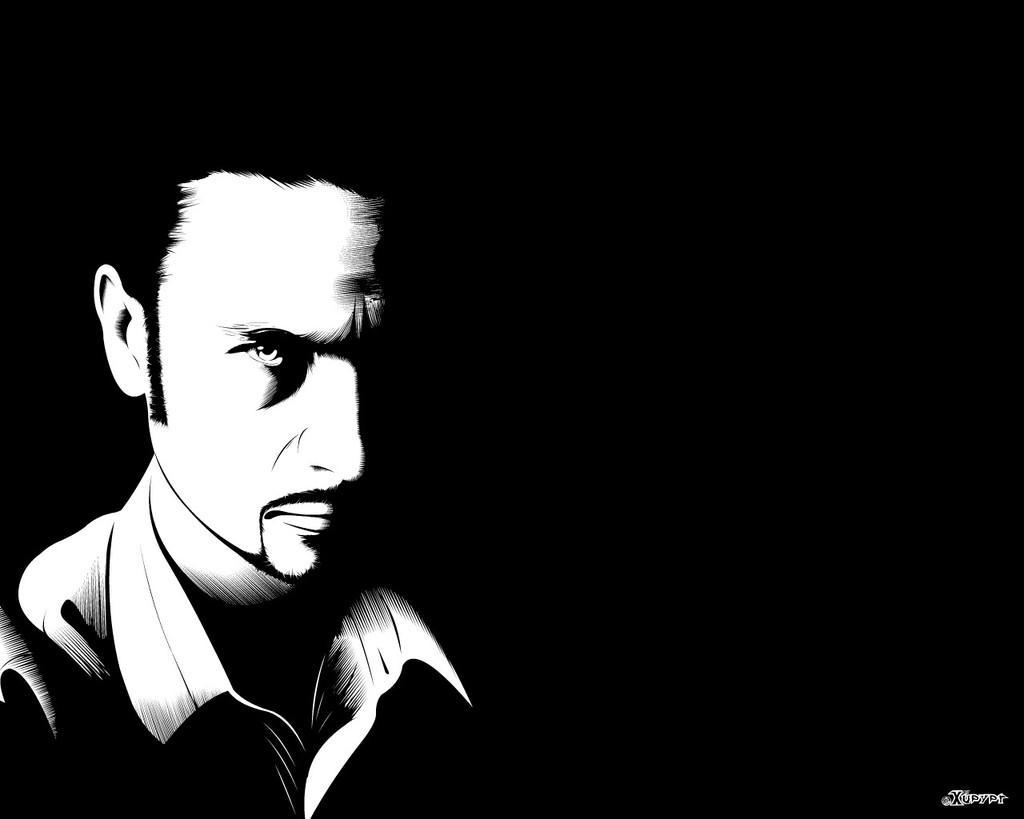Could you give a brief overview of what you see in this image? In this black and white edited image there is a man. The background is dark. In the bottom right there is text on the image. 